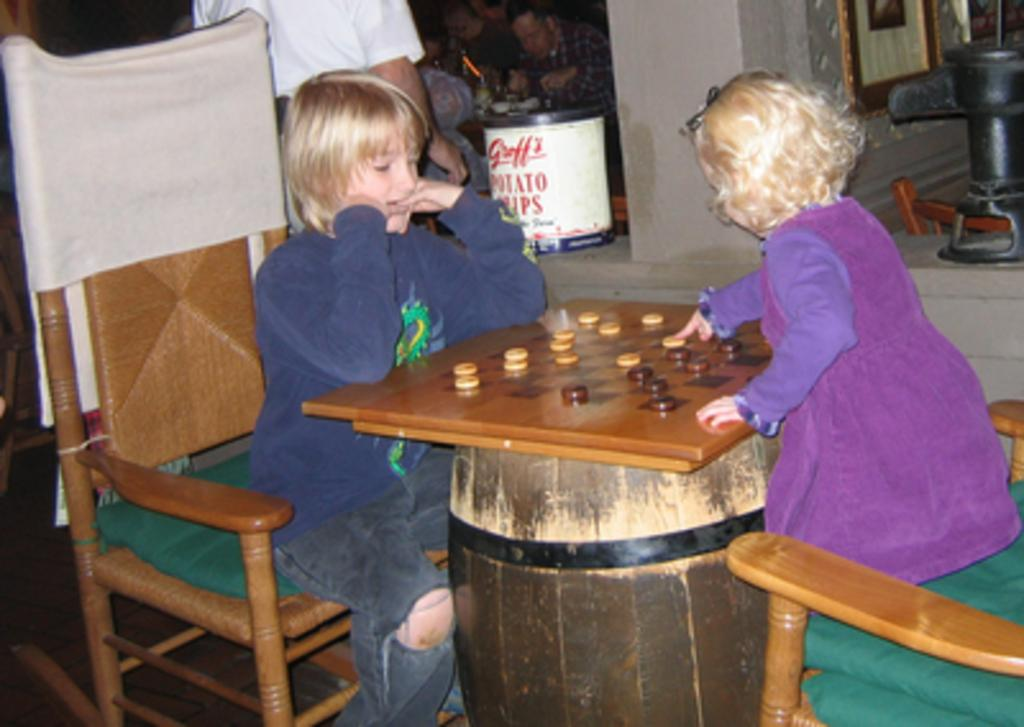What are the children doing in the image? The children are playing in the image. What type of activity are the children engaged in? The children are playing a game. Can you describe the man in the background of the image? There is a man standing in the background of the image. What objects can be seen in the background of the image? There is a bin and a wall in the background of the image. What type of gun can be seen in the image? There is no gun present in the image. How many times did the children fall during their game in the image? The image does not provide information about the children falling during their game. 